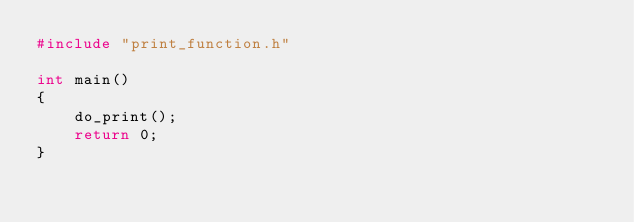Convert code to text. <code><loc_0><loc_0><loc_500><loc_500><_C_>#include "print_function.h"

int main()
{
    do_print();
    return 0;
}
</code> 